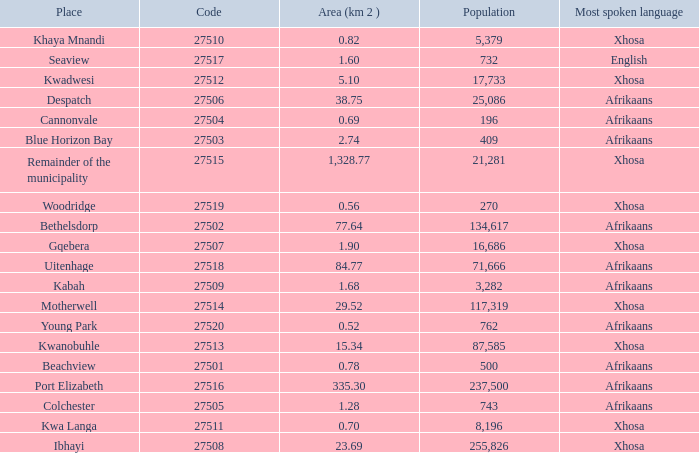What is the total number of area listed for cannonvale with a population less than 409? 1.0. 